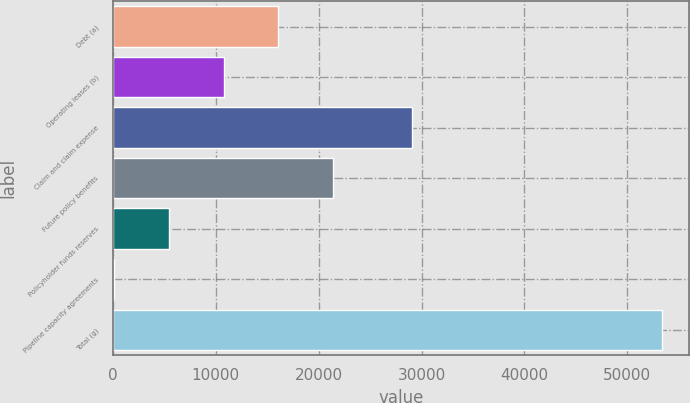<chart> <loc_0><loc_0><loc_500><loc_500><bar_chart><fcel>Debt (a)<fcel>Operating leases (b)<fcel>Claim and claim expense<fcel>Future policy benefits<fcel>Policyholder funds reserves<fcel>Pipeline capacity agreements<fcel>Total (g)<nl><fcel>16087<fcel>10759<fcel>29104<fcel>21415<fcel>5431<fcel>103<fcel>53383<nl></chart> 